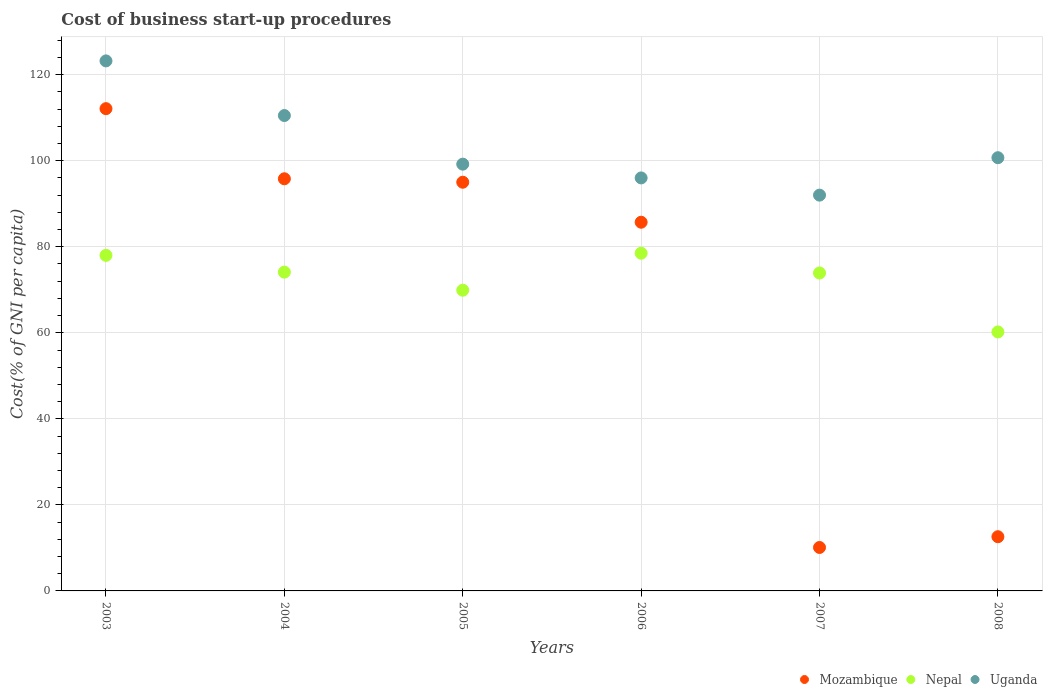How many different coloured dotlines are there?
Offer a very short reply. 3. Is the number of dotlines equal to the number of legend labels?
Give a very brief answer. Yes. What is the cost of business start-up procedures in Nepal in 2003?
Provide a short and direct response. 78. Across all years, what is the maximum cost of business start-up procedures in Uganda?
Your response must be concise. 123.2. Across all years, what is the minimum cost of business start-up procedures in Mozambique?
Keep it short and to the point. 10.1. What is the total cost of business start-up procedures in Nepal in the graph?
Offer a very short reply. 434.6. What is the difference between the cost of business start-up procedures in Nepal in 2003 and that in 2004?
Keep it short and to the point. 3.9. What is the difference between the cost of business start-up procedures in Mozambique in 2005 and the cost of business start-up procedures in Uganda in 2007?
Make the answer very short. 3. What is the average cost of business start-up procedures in Nepal per year?
Offer a terse response. 72.43. In the year 2003, what is the difference between the cost of business start-up procedures in Mozambique and cost of business start-up procedures in Uganda?
Your answer should be compact. -11.1. In how many years, is the cost of business start-up procedures in Nepal greater than 96 %?
Provide a succinct answer. 0. What is the ratio of the cost of business start-up procedures in Nepal in 2003 to that in 2005?
Offer a very short reply. 1.12. Is the cost of business start-up procedures in Uganda in 2004 less than that in 2007?
Give a very brief answer. No. Is the difference between the cost of business start-up procedures in Mozambique in 2003 and 2005 greater than the difference between the cost of business start-up procedures in Uganda in 2003 and 2005?
Provide a succinct answer. No. What is the difference between the highest and the second highest cost of business start-up procedures in Mozambique?
Your answer should be compact. 16.3. What is the difference between the highest and the lowest cost of business start-up procedures in Mozambique?
Offer a very short reply. 102. Is the cost of business start-up procedures in Mozambique strictly greater than the cost of business start-up procedures in Uganda over the years?
Keep it short and to the point. No. Is the cost of business start-up procedures in Mozambique strictly less than the cost of business start-up procedures in Nepal over the years?
Your response must be concise. No. How many years are there in the graph?
Provide a succinct answer. 6. What is the difference between two consecutive major ticks on the Y-axis?
Your answer should be very brief. 20. Does the graph contain any zero values?
Provide a succinct answer. No. How are the legend labels stacked?
Your response must be concise. Horizontal. What is the title of the graph?
Your answer should be very brief. Cost of business start-up procedures. What is the label or title of the X-axis?
Give a very brief answer. Years. What is the label or title of the Y-axis?
Offer a terse response. Cost(% of GNI per capita). What is the Cost(% of GNI per capita) in Mozambique in 2003?
Your response must be concise. 112.1. What is the Cost(% of GNI per capita) of Uganda in 2003?
Your answer should be compact. 123.2. What is the Cost(% of GNI per capita) of Mozambique in 2004?
Provide a succinct answer. 95.8. What is the Cost(% of GNI per capita) in Nepal in 2004?
Provide a short and direct response. 74.1. What is the Cost(% of GNI per capita) in Uganda in 2004?
Your answer should be very brief. 110.5. What is the Cost(% of GNI per capita) in Nepal in 2005?
Your answer should be very brief. 69.9. What is the Cost(% of GNI per capita) of Uganda in 2005?
Your response must be concise. 99.2. What is the Cost(% of GNI per capita) in Mozambique in 2006?
Offer a terse response. 85.7. What is the Cost(% of GNI per capita) in Nepal in 2006?
Your response must be concise. 78.5. What is the Cost(% of GNI per capita) in Uganda in 2006?
Make the answer very short. 96. What is the Cost(% of GNI per capita) in Nepal in 2007?
Ensure brevity in your answer.  73.9. What is the Cost(% of GNI per capita) in Uganda in 2007?
Your response must be concise. 92. What is the Cost(% of GNI per capita) in Nepal in 2008?
Make the answer very short. 60.2. What is the Cost(% of GNI per capita) of Uganda in 2008?
Give a very brief answer. 100.7. Across all years, what is the maximum Cost(% of GNI per capita) of Mozambique?
Make the answer very short. 112.1. Across all years, what is the maximum Cost(% of GNI per capita) in Nepal?
Your answer should be very brief. 78.5. Across all years, what is the maximum Cost(% of GNI per capita) in Uganda?
Provide a short and direct response. 123.2. Across all years, what is the minimum Cost(% of GNI per capita) of Mozambique?
Provide a succinct answer. 10.1. Across all years, what is the minimum Cost(% of GNI per capita) of Nepal?
Provide a short and direct response. 60.2. Across all years, what is the minimum Cost(% of GNI per capita) of Uganda?
Offer a very short reply. 92. What is the total Cost(% of GNI per capita) in Mozambique in the graph?
Your answer should be compact. 411.3. What is the total Cost(% of GNI per capita) of Nepal in the graph?
Ensure brevity in your answer.  434.6. What is the total Cost(% of GNI per capita) in Uganda in the graph?
Give a very brief answer. 621.6. What is the difference between the Cost(% of GNI per capita) in Mozambique in 2003 and that in 2004?
Your response must be concise. 16.3. What is the difference between the Cost(% of GNI per capita) of Nepal in 2003 and that in 2004?
Offer a terse response. 3.9. What is the difference between the Cost(% of GNI per capita) of Uganda in 2003 and that in 2004?
Ensure brevity in your answer.  12.7. What is the difference between the Cost(% of GNI per capita) of Nepal in 2003 and that in 2005?
Your answer should be very brief. 8.1. What is the difference between the Cost(% of GNI per capita) in Mozambique in 2003 and that in 2006?
Make the answer very short. 26.4. What is the difference between the Cost(% of GNI per capita) of Nepal in 2003 and that in 2006?
Offer a terse response. -0.5. What is the difference between the Cost(% of GNI per capita) of Uganda in 2003 and that in 2006?
Provide a succinct answer. 27.2. What is the difference between the Cost(% of GNI per capita) in Mozambique in 2003 and that in 2007?
Your response must be concise. 102. What is the difference between the Cost(% of GNI per capita) in Uganda in 2003 and that in 2007?
Your answer should be very brief. 31.2. What is the difference between the Cost(% of GNI per capita) of Mozambique in 2003 and that in 2008?
Provide a short and direct response. 99.5. What is the difference between the Cost(% of GNI per capita) of Mozambique in 2004 and that in 2005?
Give a very brief answer. 0.8. What is the difference between the Cost(% of GNI per capita) of Mozambique in 2004 and that in 2006?
Offer a very short reply. 10.1. What is the difference between the Cost(% of GNI per capita) in Uganda in 2004 and that in 2006?
Give a very brief answer. 14.5. What is the difference between the Cost(% of GNI per capita) of Mozambique in 2004 and that in 2007?
Offer a terse response. 85.7. What is the difference between the Cost(% of GNI per capita) in Nepal in 2004 and that in 2007?
Your answer should be compact. 0.2. What is the difference between the Cost(% of GNI per capita) of Uganda in 2004 and that in 2007?
Offer a terse response. 18.5. What is the difference between the Cost(% of GNI per capita) of Mozambique in 2004 and that in 2008?
Ensure brevity in your answer.  83.2. What is the difference between the Cost(% of GNI per capita) in Uganda in 2004 and that in 2008?
Make the answer very short. 9.8. What is the difference between the Cost(% of GNI per capita) in Mozambique in 2005 and that in 2006?
Your answer should be very brief. 9.3. What is the difference between the Cost(% of GNI per capita) in Mozambique in 2005 and that in 2007?
Offer a terse response. 84.9. What is the difference between the Cost(% of GNI per capita) of Nepal in 2005 and that in 2007?
Keep it short and to the point. -4. What is the difference between the Cost(% of GNI per capita) of Mozambique in 2005 and that in 2008?
Your response must be concise. 82.4. What is the difference between the Cost(% of GNI per capita) in Mozambique in 2006 and that in 2007?
Your response must be concise. 75.6. What is the difference between the Cost(% of GNI per capita) of Nepal in 2006 and that in 2007?
Give a very brief answer. 4.6. What is the difference between the Cost(% of GNI per capita) of Uganda in 2006 and that in 2007?
Your response must be concise. 4. What is the difference between the Cost(% of GNI per capita) in Mozambique in 2006 and that in 2008?
Offer a terse response. 73.1. What is the difference between the Cost(% of GNI per capita) of Mozambique in 2007 and that in 2008?
Your response must be concise. -2.5. What is the difference between the Cost(% of GNI per capita) in Nepal in 2007 and that in 2008?
Your response must be concise. 13.7. What is the difference between the Cost(% of GNI per capita) of Uganda in 2007 and that in 2008?
Keep it short and to the point. -8.7. What is the difference between the Cost(% of GNI per capita) of Mozambique in 2003 and the Cost(% of GNI per capita) of Nepal in 2004?
Your response must be concise. 38. What is the difference between the Cost(% of GNI per capita) in Nepal in 2003 and the Cost(% of GNI per capita) in Uganda in 2004?
Keep it short and to the point. -32.5. What is the difference between the Cost(% of GNI per capita) of Mozambique in 2003 and the Cost(% of GNI per capita) of Nepal in 2005?
Provide a short and direct response. 42.2. What is the difference between the Cost(% of GNI per capita) of Mozambique in 2003 and the Cost(% of GNI per capita) of Uganda in 2005?
Keep it short and to the point. 12.9. What is the difference between the Cost(% of GNI per capita) in Nepal in 2003 and the Cost(% of GNI per capita) in Uganda in 2005?
Offer a terse response. -21.2. What is the difference between the Cost(% of GNI per capita) of Mozambique in 2003 and the Cost(% of GNI per capita) of Nepal in 2006?
Ensure brevity in your answer.  33.6. What is the difference between the Cost(% of GNI per capita) of Mozambique in 2003 and the Cost(% of GNI per capita) of Uganda in 2006?
Keep it short and to the point. 16.1. What is the difference between the Cost(% of GNI per capita) in Nepal in 2003 and the Cost(% of GNI per capita) in Uganda in 2006?
Provide a short and direct response. -18. What is the difference between the Cost(% of GNI per capita) of Mozambique in 2003 and the Cost(% of GNI per capita) of Nepal in 2007?
Your answer should be compact. 38.2. What is the difference between the Cost(% of GNI per capita) in Mozambique in 2003 and the Cost(% of GNI per capita) in Uganda in 2007?
Keep it short and to the point. 20.1. What is the difference between the Cost(% of GNI per capita) in Nepal in 2003 and the Cost(% of GNI per capita) in Uganda in 2007?
Keep it short and to the point. -14. What is the difference between the Cost(% of GNI per capita) in Mozambique in 2003 and the Cost(% of GNI per capita) in Nepal in 2008?
Your answer should be compact. 51.9. What is the difference between the Cost(% of GNI per capita) in Mozambique in 2003 and the Cost(% of GNI per capita) in Uganda in 2008?
Make the answer very short. 11.4. What is the difference between the Cost(% of GNI per capita) of Nepal in 2003 and the Cost(% of GNI per capita) of Uganda in 2008?
Offer a terse response. -22.7. What is the difference between the Cost(% of GNI per capita) in Mozambique in 2004 and the Cost(% of GNI per capita) in Nepal in 2005?
Offer a very short reply. 25.9. What is the difference between the Cost(% of GNI per capita) in Nepal in 2004 and the Cost(% of GNI per capita) in Uganda in 2005?
Provide a succinct answer. -25.1. What is the difference between the Cost(% of GNI per capita) in Mozambique in 2004 and the Cost(% of GNI per capita) in Uganda in 2006?
Give a very brief answer. -0.2. What is the difference between the Cost(% of GNI per capita) of Nepal in 2004 and the Cost(% of GNI per capita) of Uganda in 2006?
Keep it short and to the point. -21.9. What is the difference between the Cost(% of GNI per capita) in Mozambique in 2004 and the Cost(% of GNI per capita) in Nepal in 2007?
Ensure brevity in your answer.  21.9. What is the difference between the Cost(% of GNI per capita) of Mozambique in 2004 and the Cost(% of GNI per capita) of Uganda in 2007?
Keep it short and to the point. 3.8. What is the difference between the Cost(% of GNI per capita) in Nepal in 2004 and the Cost(% of GNI per capita) in Uganda in 2007?
Give a very brief answer. -17.9. What is the difference between the Cost(% of GNI per capita) in Mozambique in 2004 and the Cost(% of GNI per capita) in Nepal in 2008?
Offer a terse response. 35.6. What is the difference between the Cost(% of GNI per capita) in Mozambique in 2004 and the Cost(% of GNI per capita) in Uganda in 2008?
Give a very brief answer. -4.9. What is the difference between the Cost(% of GNI per capita) in Nepal in 2004 and the Cost(% of GNI per capita) in Uganda in 2008?
Offer a terse response. -26.6. What is the difference between the Cost(% of GNI per capita) in Mozambique in 2005 and the Cost(% of GNI per capita) in Uganda in 2006?
Offer a very short reply. -1. What is the difference between the Cost(% of GNI per capita) in Nepal in 2005 and the Cost(% of GNI per capita) in Uganda in 2006?
Offer a very short reply. -26.1. What is the difference between the Cost(% of GNI per capita) of Mozambique in 2005 and the Cost(% of GNI per capita) of Nepal in 2007?
Provide a succinct answer. 21.1. What is the difference between the Cost(% of GNI per capita) in Mozambique in 2005 and the Cost(% of GNI per capita) in Uganda in 2007?
Ensure brevity in your answer.  3. What is the difference between the Cost(% of GNI per capita) of Nepal in 2005 and the Cost(% of GNI per capita) of Uganda in 2007?
Your answer should be very brief. -22.1. What is the difference between the Cost(% of GNI per capita) in Mozambique in 2005 and the Cost(% of GNI per capita) in Nepal in 2008?
Provide a short and direct response. 34.8. What is the difference between the Cost(% of GNI per capita) of Nepal in 2005 and the Cost(% of GNI per capita) of Uganda in 2008?
Make the answer very short. -30.8. What is the difference between the Cost(% of GNI per capita) in Mozambique in 2006 and the Cost(% of GNI per capita) in Nepal in 2008?
Provide a short and direct response. 25.5. What is the difference between the Cost(% of GNI per capita) of Nepal in 2006 and the Cost(% of GNI per capita) of Uganda in 2008?
Provide a succinct answer. -22.2. What is the difference between the Cost(% of GNI per capita) in Mozambique in 2007 and the Cost(% of GNI per capita) in Nepal in 2008?
Your answer should be very brief. -50.1. What is the difference between the Cost(% of GNI per capita) in Mozambique in 2007 and the Cost(% of GNI per capita) in Uganda in 2008?
Ensure brevity in your answer.  -90.6. What is the difference between the Cost(% of GNI per capita) in Nepal in 2007 and the Cost(% of GNI per capita) in Uganda in 2008?
Provide a short and direct response. -26.8. What is the average Cost(% of GNI per capita) of Mozambique per year?
Ensure brevity in your answer.  68.55. What is the average Cost(% of GNI per capita) of Nepal per year?
Make the answer very short. 72.43. What is the average Cost(% of GNI per capita) of Uganda per year?
Your response must be concise. 103.6. In the year 2003, what is the difference between the Cost(% of GNI per capita) of Mozambique and Cost(% of GNI per capita) of Nepal?
Your answer should be very brief. 34.1. In the year 2003, what is the difference between the Cost(% of GNI per capita) in Mozambique and Cost(% of GNI per capita) in Uganda?
Keep it short and to the point. -11.1. In the year 2003, what is the difference between the Cost(% of GNI per capita) of Nepal and Cost(% of GNI per capita) of Uganda?
Offer a very short reply. -45.2. In the year 2004, what is the difference between the Cost(% of GNI per capita) in Mozambique and Cost(% of GNI per capita) in Nepal?
Your answer should be very brief. 21.7. In the year 2004, what is the difference between the Cost(% of GNI per capita) of Mozambique and Cost(% of GNI per capita) of Uganda?
Provide a succinct answer. -14.7. In the year 2004, what is the difference between the Cost(% of GNI per capita) in Nepal and Cost(% of GNI per capita) in Uganda?
Your answer should be compact. -36.4. In the year 2005, what is the difference between the Cost(% of GNI per capita) in Mozambique and Cost(% of GNI per capita) in Nepal?
Make the answer very short. 25.1. In the year 2005, what is the difference between the Cost(% of GNI per capita) of Nepal and Cost(% of GNI per capita) of Uganda?
Offer a very short reply. -29.3. In the year 2006, what is the difference between the Cost(% of GNI per capita) in Mozambique and Cost(% of GNI per capita) in Uganda?
Offer a very short reply. -10.3. In the year 2006, what is the difference between the Cost(% of GNI per capita) of Nepal and Cost(% of GNI per capita) of Uganda?
Provide a succinct answer. -17.5. In the year 2007, what is the difference between the Cost(% of GNI per capita) of Mozambique and Cost(% of GNI per capita) of Nepal?
Offer a very short reply. -63.8. In the year 2007, what is the difference between the Cost(% of GNI per capita) in Mozambique and Cost(% of GNI per capita) in Uganda?
Offer a terse response. -81.9. In the year 2007, what is the difference between the Cost(% of GNI per capita) in Nepal and Cost(% of GNI per capita) in Uganda?
Ensure brevity in your answer.  -18.1. In the year 2008, what is the difference between the Cost(% of GNI per capita) in Mozambique and Cost(% of GNI per capita) in Nepal?
Keep it short and to the point. -47.6. In the year 2008, what is the difference between the Cost(% of GNI per capita) of Mozambique and Cost(% of GNI per capita) of Uganda?
Provide a succinct answer. -88.1. In the year 2008, what is the difference between the Cost(% of GNI per capita) of Nepal and Cost(% of GNI per capita) of Uganda?
Give a very brief answer. -40.5. What is the ratio of the Cost(% of GNI per capita) of Mozambique in 2003 to that in 2004?
Offer a terse response. 1.17. What is the ratio of the Cost(% of GNI per capita) in Nepal in 2003 to that in 2004?
Ensure brevity in your answer.  1.05. What is the ratio of the Cost(% of GNI per capita) of Uganda in 2003 to that in 2004?
Your answer should be very brief. 1.11. What is the ratio of the Cost(% of GNI per capita) in Mozambique in 2003 to that in 2005?
Your answer should be compact. 1.18. What is the ratio of the Cost(% of GNI per capita) of Nepal in 2003 to that in 2005?
Offer a terse response. 1.12. What is the ratio of the Cost(% of GNI per capita) of Uganda in 2003 to that in 2005?
Provide a succinct answer. 1.24. What is the ratio of the Cost(% of GNI per capita) of Mozambique in 2003 to that in 2006?
Provide a short and direct response. 1.31. What is the ratio of the Cost(% of GNI per capita) of Nepal in 2003 to that in 2006?
Keep it short and to the point. 0.99. What is the ratio of the Cost(% of GNI per capita) of Uganda in 2003 to that in 2006?
Offer a terse response. 1.28. What is the ratio of the Cost(% of GNI per capita) of Mozambique in 2003 to that in 2007?
Keep it short and to the point. 11.1. What is the ratio of the Cost(% of GNI per capita) of Nepal in 2003 to that in 2007?
Offer a very short reply. 1.06. What is the ratio of the Cost(% of GNI per capita) in Uganda in 2003 to that in 2007?
Your answer should be very brief. 1.34. What is the ratio of the Cost(% of GNI per capita) of Mozambique in 2003 to that in 2008?
Your answer should be compact. 8.9. What is the ratio of the Cost(% of GNI per capita) in Nepal in 2003 to that in 2008?
Offer a terse response. 1.3. What is the ratio of the Cost(% of GNI per capita) in Uganda in 2003 to that in 2008?
Your response must be concise. 1.22. What is the ratio of the Cost(% of GNI per capita) in Mozambique in 2004 to that in 2005?
Make the answer very short. 1.01. What is the ratio of the Cost(% of GNI per capita) in Nepal in 2004 to that in 2005?
Keep it short and to the point. 1.06. What is the ratio of the Cost(% of GNI per capita) in Uganda in 2004 to that in 2005?
Keep it short and to the point. 1.11. What is the ratio of the Cost(% of GNI per capita) in Mozambique in 2004 to that in 2006?
Your answer should be compact. 1.12. What is the ratio of the Cost(% of GNI per capita) in Nepal in 2004 to that in 2006?
Your answer should be very brief. 0.94. What is the ratio of the Cost(% of GNI per capita) in Uganda in 2004 to that in 2006?
Provide a succinct answer. 1.15. What is the ratio of the Cost(% of GNI per capita) in Mozambique in 2004 to that in 2007?
Your answer should be very brief. 9.49. What is the ratio of the Cost(% of GNI per capita) in Uganda in 2004 to that in 2007?
Make the answer very short. 1.2. What is the ratio of the Cost(% of GNI per capita) of Mozambique in 2004 to that in 2008?
Provide a short and direct response. 7.6. What is the ratio of the Cost(% of GNI per capita) of Nepal in 2004 to that in 2008?
Provide a succinct answer. 1.23. What is the ratio of the Cost(% of GNI per capita) of Uganda in 2004 to that in 2008?
Your response must be concise. 1.1. What is the ratio of the Cost(% of GNI per capita) of Mozambique in 2005 to that in 2006?
Offer a terse response. 1.11. What is the ratio of the Cost(% of GNI per capita) in Nepal in 2005 to that in 2006?
Offer a very short reply. 0.89. What is the ratio of the Cost(% of GNI per capita) in Uganda in 2005 to that in 2006?
Your answer should be compact. 1.03. What is the ratio of the Cost(% of GNI per capita) in Mozambique in 2005 to that in 2007?
Offer a very short reply. 9.41. What is the ratio of the Cost(% of GNI per capita) in Nepal in 2005 to that in 2007?
Offer a very short reply. 0.95. What is the ratio of the Cost(% of GNI per capita) of Uganda in 2005 to that in 2007?
Provide a succinct answer. 1.08. What is the ratio of the Cost(% of GNI per capita) in Mozambique in 2005 to that in 2008?
Give a very brief answer. 7.54. What is the ratio of the Cost(% of GNI per capita) in Nepal in 2005 to that in 2008?
Your answer should be compact. 1.16. What is the ratio of the Cost(% of GNI per capita) in Uganda in 2005 to that in 2008?
Make the answer very short. 0.99. What is the ratio of the Cost(% of GNI per capita) of Mozambique in 2006 to that in 2007?
Provide a succinct answer. 8.49. What is the ratio of the Cost(% of GNI per capita) of Nepal in 2006 to that in 2007?
Provide a short and direct response. 1.06. What is the ratio of the Cost(% of GNI per capita) in Uganda in 2006 to that in 2007?
Your answer should be very brief. 1.04. What is the ratio of the Cost(% of GNI per capita) in Mozambique in 2006 to that in 2008?
Offer a terse response. 6.8. What is the ratio of the Cost(% of GNI per capita) of Nepal in 2006 to that in 2008?
Make the answer very short. 1.3. What is the ratio of the Cost(% of GNI per capita) in Uganda in 2006 to that in 2008?
Give a very brief answer. 0.95. What is the ratio of the Cost(% of GNI per capita) of Mozambique in 2007 to that in 2008?
Keep it short and to the point. 0.8. What is the ratio of the Cost(% of GNI per capita) of Nepal in 2007 to that in 2008?
Ensure brevity in your answer.  1.23. What is the ratio of the Cost(% of GNI per capita) in Uganda in 2007 to that in 2008?
Your answer should be compact. 0.91. What is the difference between the highest and the second highest Cost(% of GNI per capita) in Mozambique?
Your answer should be compact. 16.3. What is the difference between the highest and the second highest Cost(% of GNI per capita) of Uganda?
Provide a succinct answer. 12.7. What is the difference between the highest and the lowest Cost(% of GNI per capita) of Mozambique?
Your answer should be very brief. 102. What is the difference between the highest and the lowest Cost(% of GNI per capita) of Nepal?
Ensure brevity in your answer.  18.3. What is the difference between the highest and the lowest Cost(% of GNI per capita) in Uganda?
Ensure brevity in your answer.  31.2. 